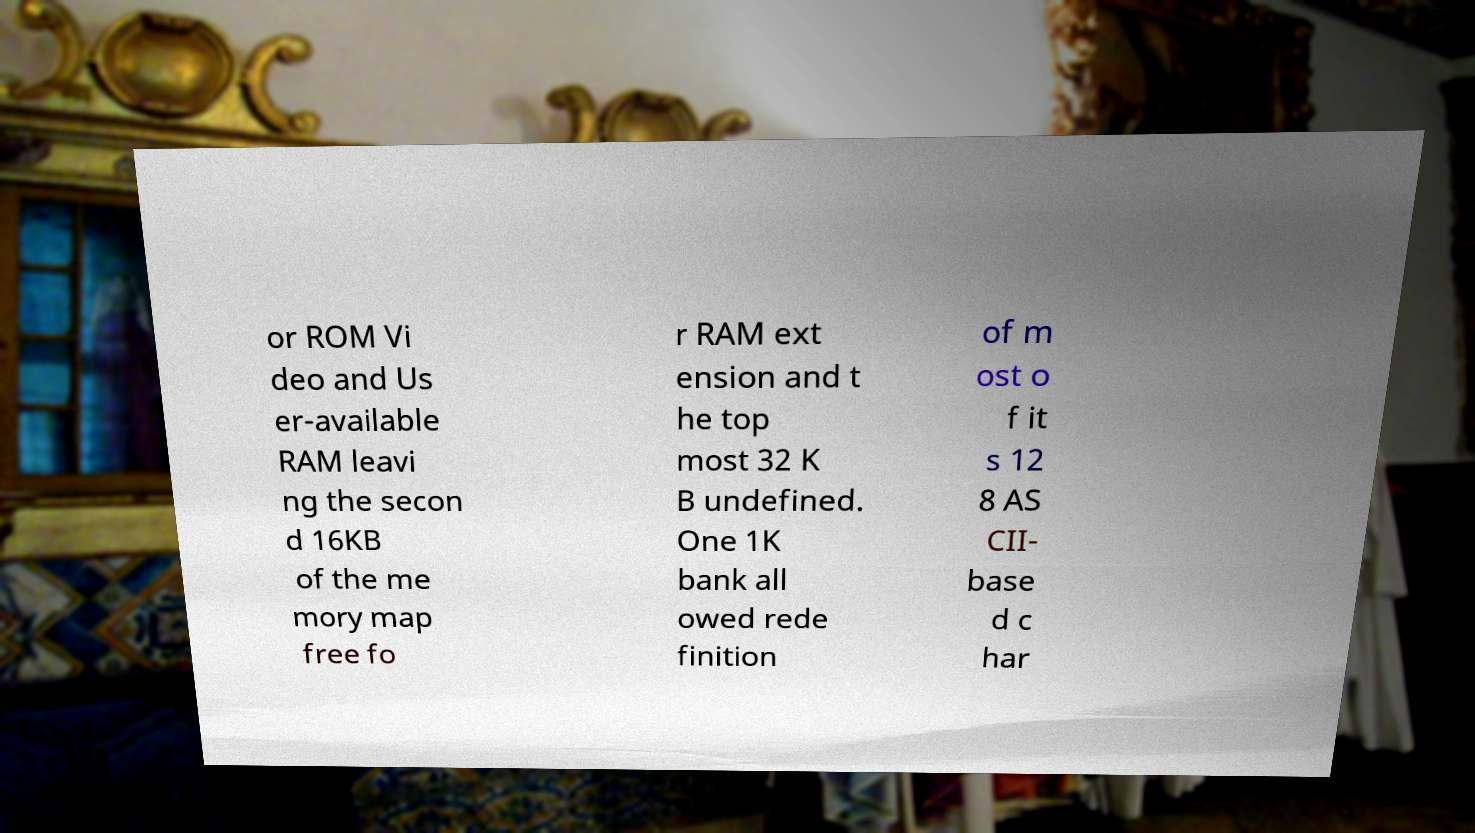For documentation purposes, I need the text within this image transcribed. Could you provide that? or ROM Vi deo and Us er-available RAM leavi ng the secon d 16KB of the me mory map free fo r RAM ext ension and t he top most 32 K B undefined. One 1K bank all owed rede finition of m ost o f it s 12 8 AS CII- base d c har 